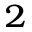Convert formula to latex. <formula><loc_0><loc_0><loc_500><loc_500>_ { 2 }</formula> 